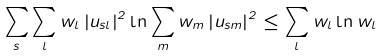<formula> <loc_0><loc_0><loc_500><loc_500>\sum _ { s } \sum _ { l } w _ { l } \left | u _ { s l } \right | ^ { 2 } \ln \sum _ { m } w _ { m } \left | u _ { s m } \right | ^ { 2 } \leq \sum _ { l } w _ { l } \ln w _ { l }</formula> 